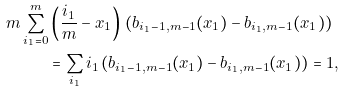Convert formula to latex. <formula><loc_0><loc_0><loc_500><loc_500>m \sum _ { i _ { 1 } = 0 } ^ { m } & \left ( \frac { i _ { 1 } } { m } - x _ { 1 } \right ) \, ( b _ { i _ { 1 } - 1 , m - 1 } ( x _ { 1 } ) - b _ { i _ { 1 } , m - 1 } ( x _ { 1 } ) ) \\ & = \sum _ { i _ { 1 } } i _ { 1 } \, ( b _ { i _ { 1 } - 1 , m - 1 } ( x _ { 1 } ) - b _ { i _ { 1 } , m - 1 } ( x _ { 1 } ) ) = 1 ,</formula> 